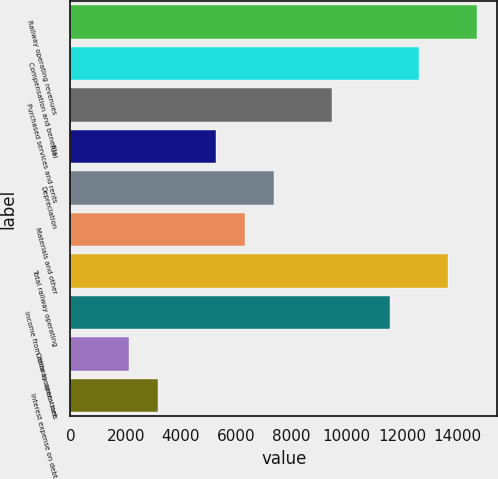<chart> <loc_0><loc_0><loc_500><loc_500><bar_chart><fcel>Railway operating revenues<fcel>Compensation and benefits<fcel>Purchased services and rents<fcel>Fuel<fcel>Depreciation<fcel>Materials and other<fcel>Total railway operating<fcel>Income from railway operations<fcel>Other income - net<fcel>Interest expense on debt<nl><fcel>14713.4<fcel>12612.2<fcel>9460.41<fcel>5258.05<fcel>7359.23<fcel>6308.64<fcel>13662.8<fcel>11561.6<fcel>2106.28<fcel>3156.87<nl></chart> 